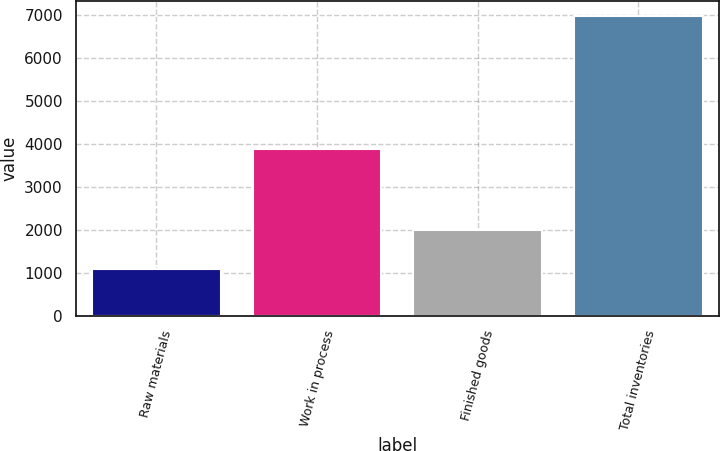<chart> <loc_0><loc_0><loc_500><loc_500><bar_chart><fcel>Raw materials<fcel>Work in process<fcel>Finished goods<fcel>Total inventories<nl><fcel>1098<fcel>3893<fcel>1992<fcel>6983<nl></chart> 